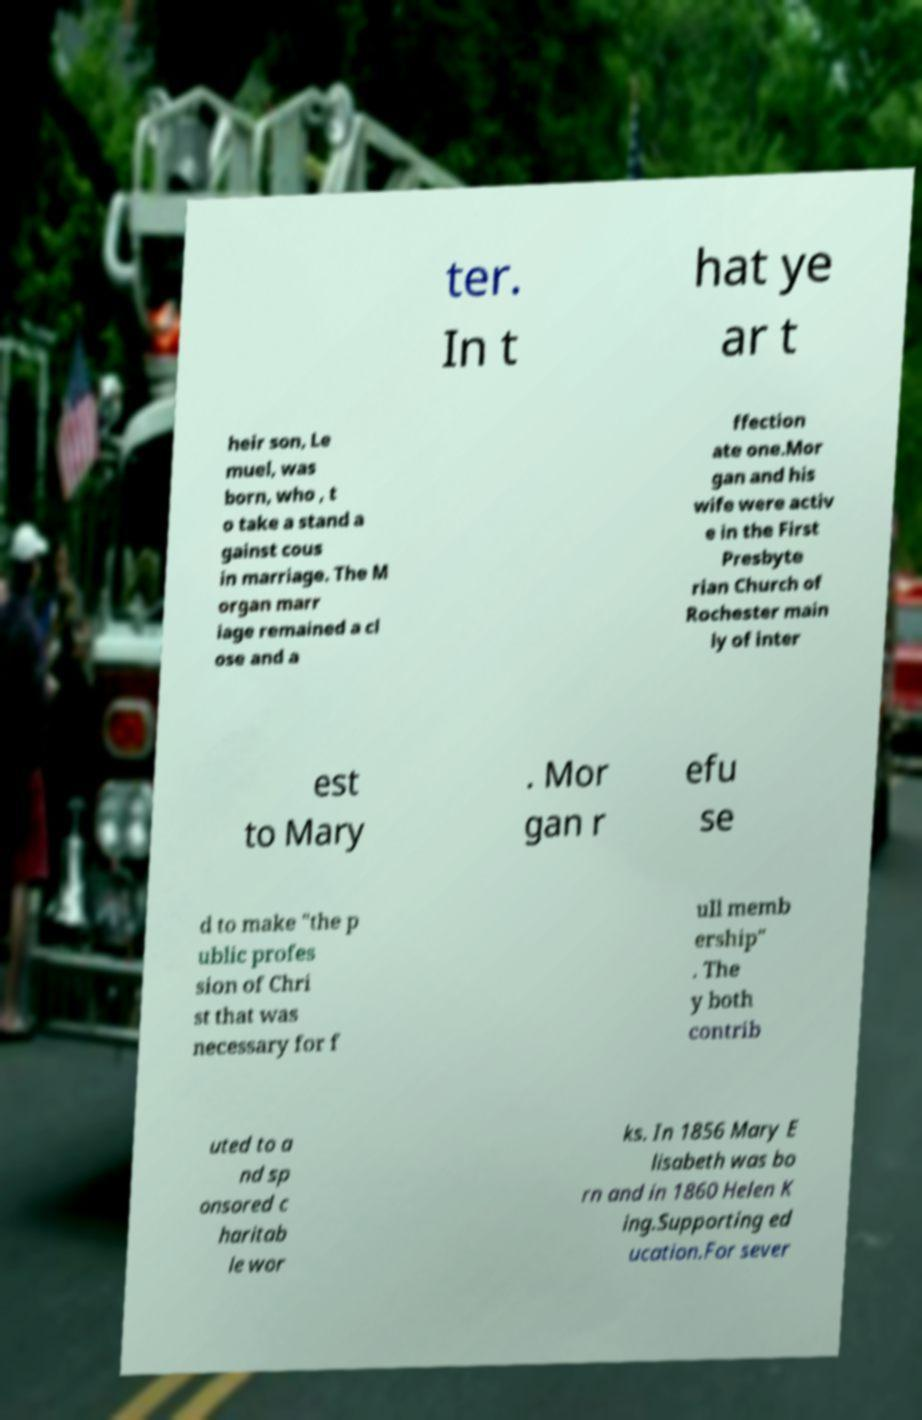Can you read and provide the text displayed in the image?This photo seems to have some interesting text. Can you extract and type it out for me? ter. In t hat ye ar t heir son, Le muel, was born, who , t o take a stand a gainst cous in marriage. The M organ marr iage remained a cl ose and a ffection ate one.Mor gan and his wife were activ e in the First Presbyte rian Church of Rochester main ly of inter est to Mary . Mor gan r efu se d to make "the p ublic profes sion of Chri st that was necessary for f ull memb ership" . The y both contrib uted to a nd sp onsored c haritab le wor ks. In 1856 Mary E lisabeth was bo rn and in 1860 Helen K ing.Supporting ed ucation.For sever 